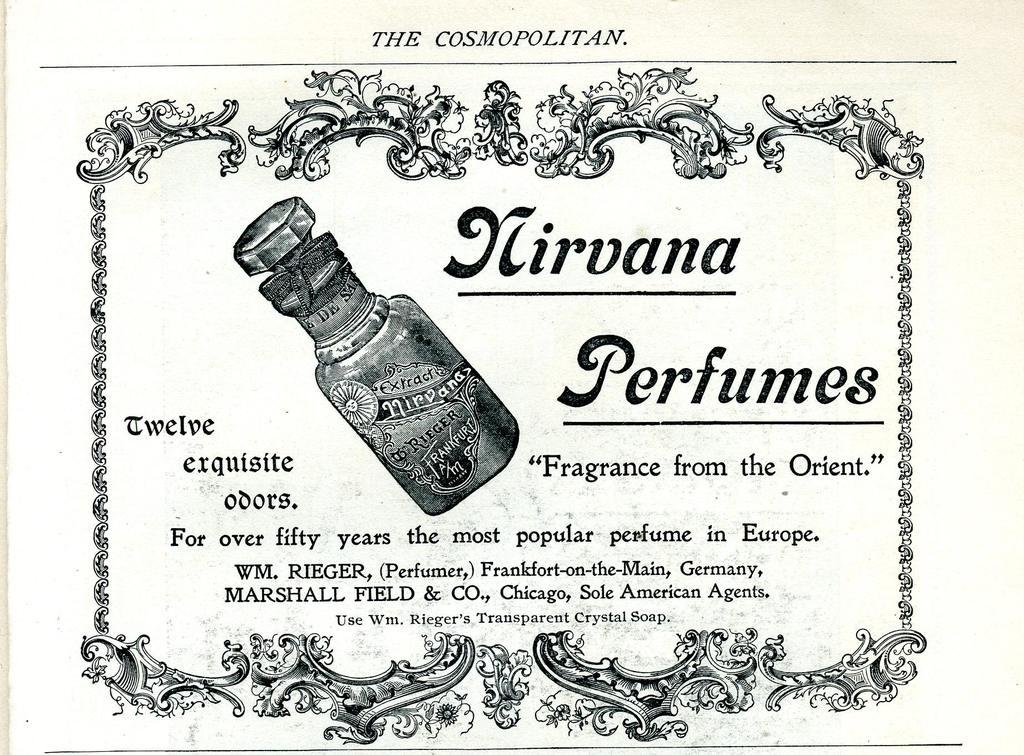<image>
Relay a brief, clear account of the picture shown. Paper showing the Cosmopolitan and a picture of a can on it. 